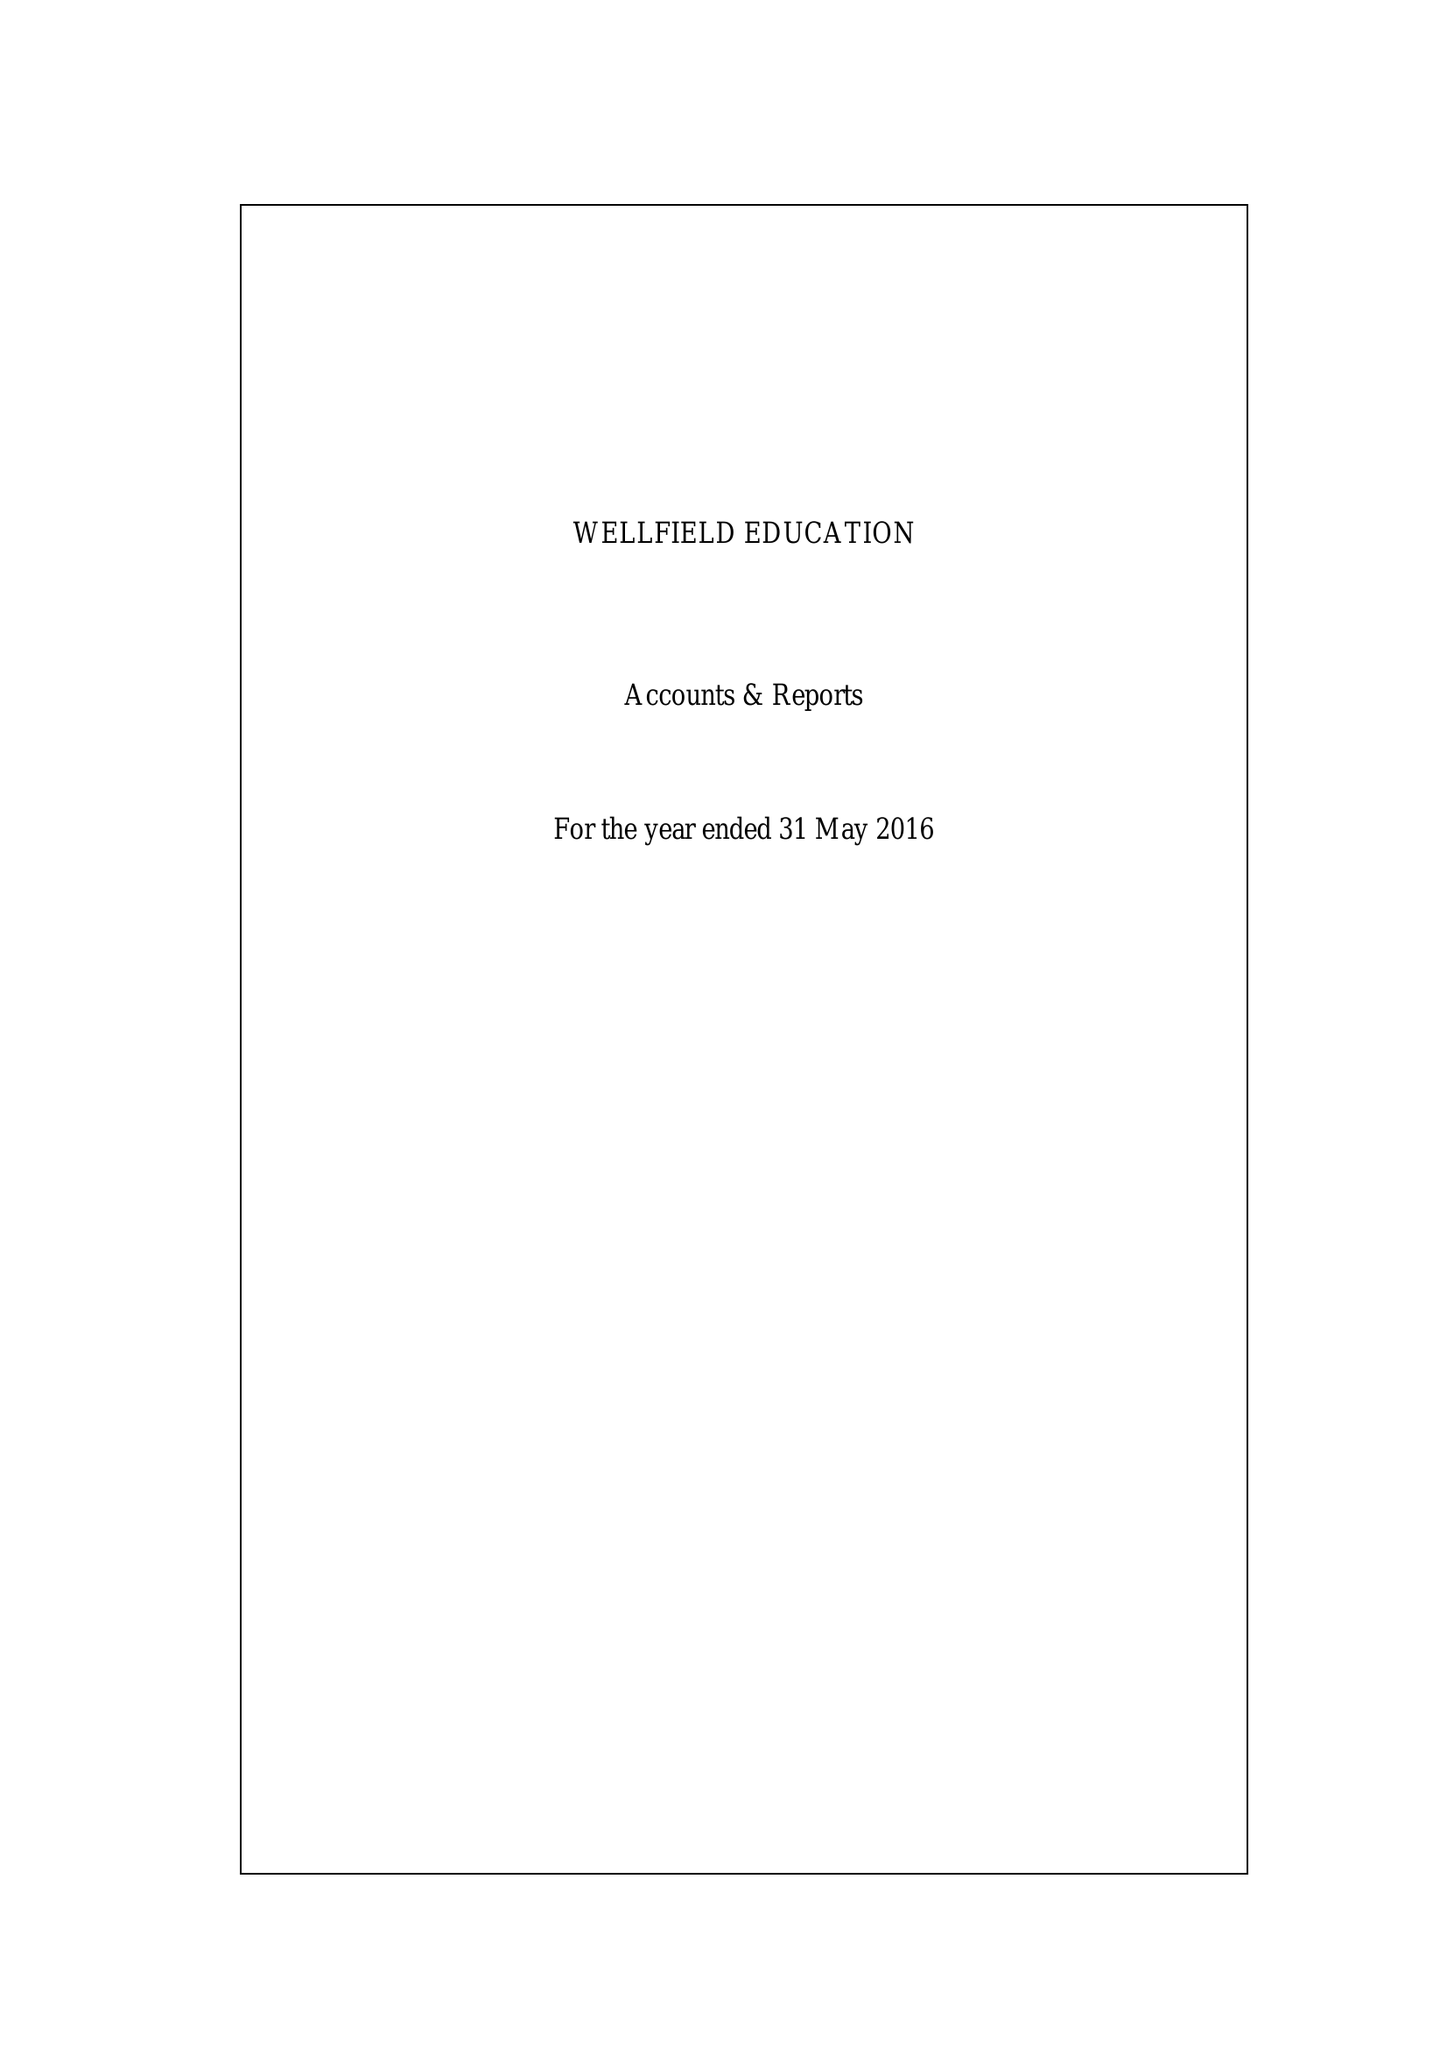What is the value for the income_annually_in_british_pounds?
Answer the question using a single word or phrase. 172515.00 